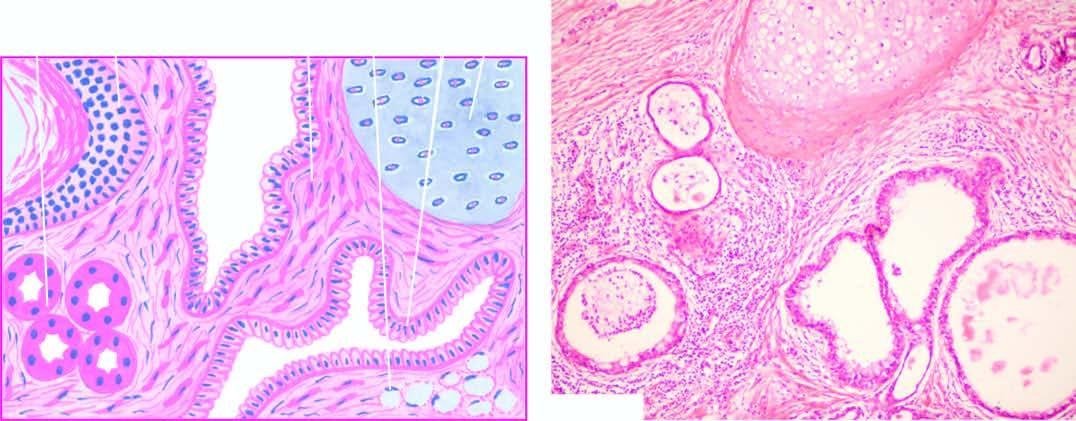does microscopy show characteristic lining of the cyst wall by epidermis and its appendages?
Answer the question using a single word or phrase. Yes 